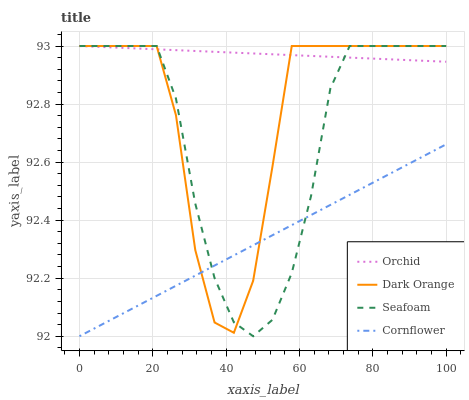Does Cornflower have the minimum area under the curve?
Answer yes or no. Yes. Does Orchid have the maximum area under the curve?
Answer yes or no. Yes. Does Seafoam have the minimum area under the curve?
Answer yes or no. No. Does Seafoam have the maximum area under the curve?
Answer yes or no. No. Is Cornflower the smoothest?
Answer yes or no. Yes. Is Dark Orange the roughest?
Answer yes or no. Yes. Is Seafoam the smoothest?
Answer yes or no. No. Is Seafoam the roughest?
Answer yes or no. No. Does Cornflower have the lowest value?
Answer yes or no. Yes. Does Seafoam have the lowest value?
Answer yes or no. No. Does Orchid have the highest value?
Answer yes or no. Yes. Does Cornflower have the highest value?
Answer yes or no. No. Is Cornflower less than Orchid?
Answer yes or no. Yes. Is Orchid greater than Cornflower?
Answer yes or no. Yes. Does Seafoam intersect Dark Orange?
Answer yes or no. Yes. Is Seafoam less than Dark Orange?
Answer yes or no. No. Is Seafoam greater than Dark Orange?
Answer yes or no. No. Does Cornflower intersect Orchid?
Answer yes or no. No. 